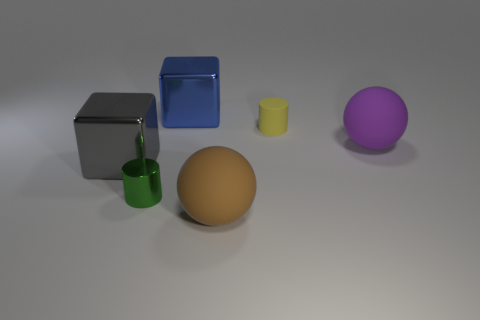There is another large object that is the same material as the gray object; what color is it?
Your answer should be compact. Blue. How many tiny blue balls are made of the same material as the large brown thing?
Offer a terse response. 0. How many objects are large blocks or big matte balls to the left of the tiny matte cylinder?
Give a very brief answer. 3. Is the material of the cylinder on the left side of the brown rubber sphere the same as the large brown thing?
Your answer should be compact. No. There is a matte thing that is the same size as the shiny cylinder; what color is it?
Ensure brevity in your answer.  Yellow. Is there another object of the same shape as the yellow object?
Your answer should be compact. Yes. The big rubber sphere in front of the big matte thing behind the big matte thing in front of the tiny metal object is what color?
Your answer should be compact. Brown. How many metallic things are blocks or yellow cylinders?
Make the answer very short. 2. Are there more purple rubber spheres that are in front of the brown thing than big blue objects on the left side of the small green metallic thing?
Offer a terse response. No. What number of other things are the same size as the green cylinder?
Your answer should be very brief. 1. 